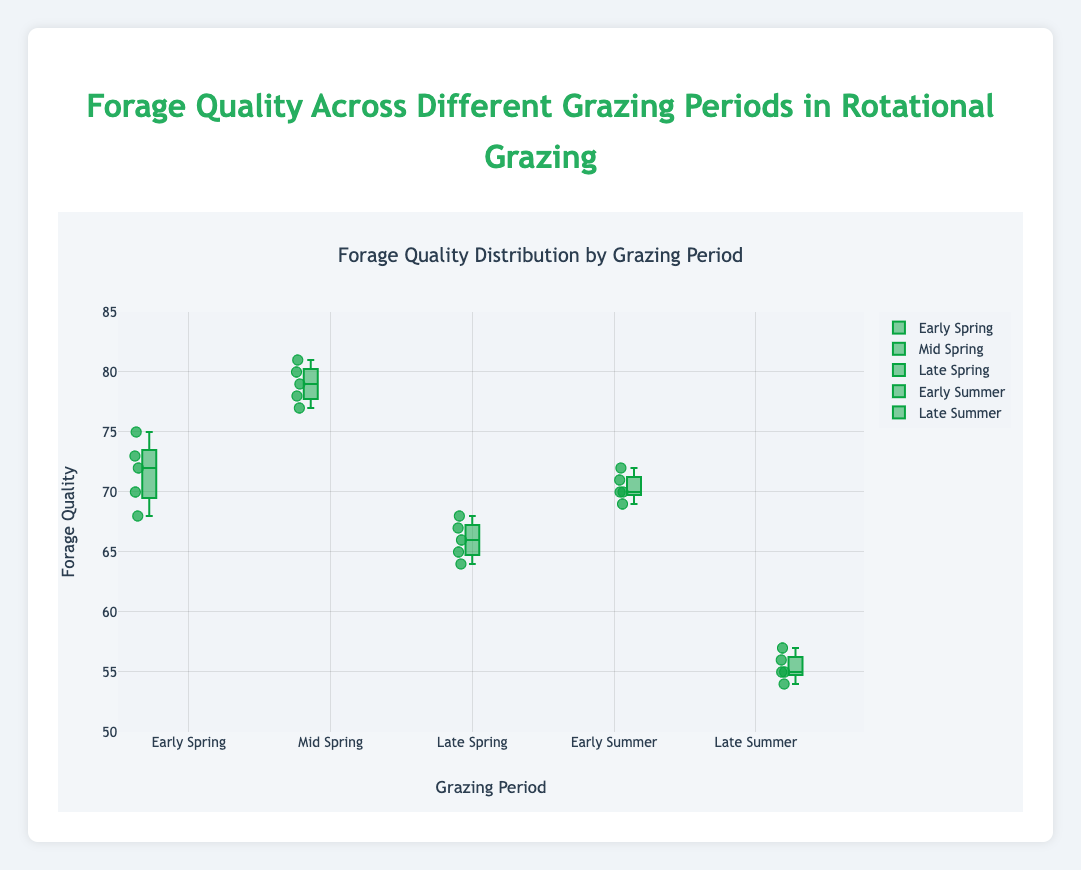What is the title of the figure? The title is located at the top center of the figure and provides an overview of the data being presented.
Answer: Forage Quality Across Different Grazing Periods in Rotational Grazing What is the range of Forage Quality values on the y-axis? The y-axis has a title and specified range that indicates the scope of the data along this axis. The range is set visually on the left side of the plot.
Answer: 50 to 85 Which grazing period has the highest median forage quality? To determine this, we look at the center line of each box in the plot that represents the median. By comparing these lines, we see which is positioned higher on the y-axis.
Answer: Mid Spring Which grazing period has the lowest forage quality outlier? Outliers are individual points that fall outside the interquartile range. By scanning for the lowest points beyond the typical range of the boxes, we can identify the period.
Answer: Late Summer What is the interquartile range (IQR) for forage quality during Early Spring? The IQR is the range between the first quartile (bottom of the box) and the third quartile (top of the box). Check the height of the box for Early Spring.
Answer: 68 to 73 Which grazing period shows the most consistent forage quality, and why? Consistency can be measured by the spread of the boxes. The period with the smallest box width indicates lesser variation and therefore greater consistency.
Answer: Early Summer, smallest box During which grazing period is the forage quality most variable? The variability is indicated by the length of the box and the whiskers. The longer the box and whiskers, the more variable the data.
Answer: Late Summer Calculate the average forage quality for Early Summer? To find the average, we add up all the forage quality values for Early Summer and divide by the number of data points. (70 + 71 + 69 + 72 + 70) = 352, so 352/5 = 70.4
Answer: 70.4 Compare the interquartile ranges of Early Spring and Late Spring. Which has the larger range? Observe the spread of the boxes for both periods and measure the distance between the first and third quartiles. Early Spring's IQR is 5 (73-68), and Late Spring's IQR is 4 (68-64).
Answer: Early Spring Are there any grazing periods where the forage quality does not exceed 80? Review the highest whisker or outlier points for each period to see if they reach up to 80 or not.
Answer: Yes, no periods exceed 80 